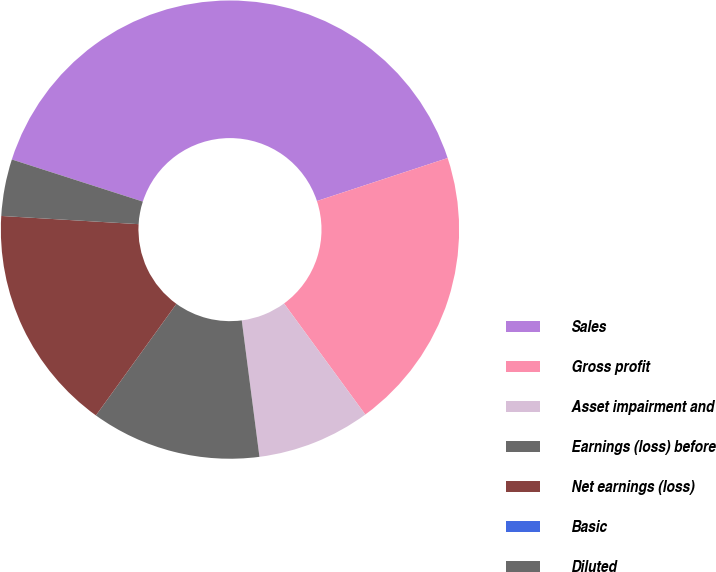Convert chart to OTSL. <chart><loc_0><loc_0><loc_500><loc_500><pie_chart><fcel>Sales<fcel>Gross profit<fcel>Asset impairment and<fcel>Earnings (loss) before<fcel>Net earnings (loss)<fcel>Basic<fcel>Diluted<nl><fcel>39.99%<fcel>20.0%<fcel>8.0%<fcel>12.0%<fcel>16.0%<fcel>0.0%<fcel>4.0%<nl></chart> 